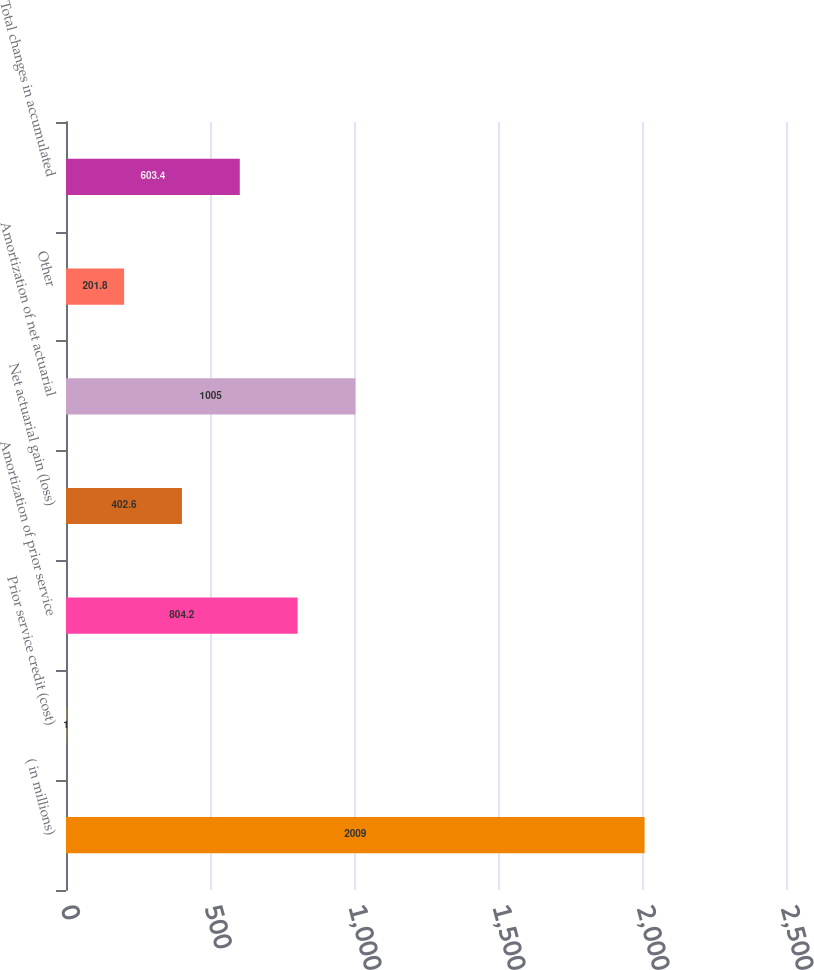Convert chart to OTSL. <chart><loc_0><loc_0><loc_500><loc_500><bar_chart><fcel>( in millions)<fcel>Prior service credit (cost)<fcel>Amortization of prior service<fcel>Net actuarial gain (loss)<fcel>Amortization of net actuarial<fcel>Other<fcel>Total changes in accumulated<nl><fcel>2009<fcel>1<fcel>804.2<fcel>402.6<fcel>1005<fcel>201.8<fcel>603.4<nl></chart> 